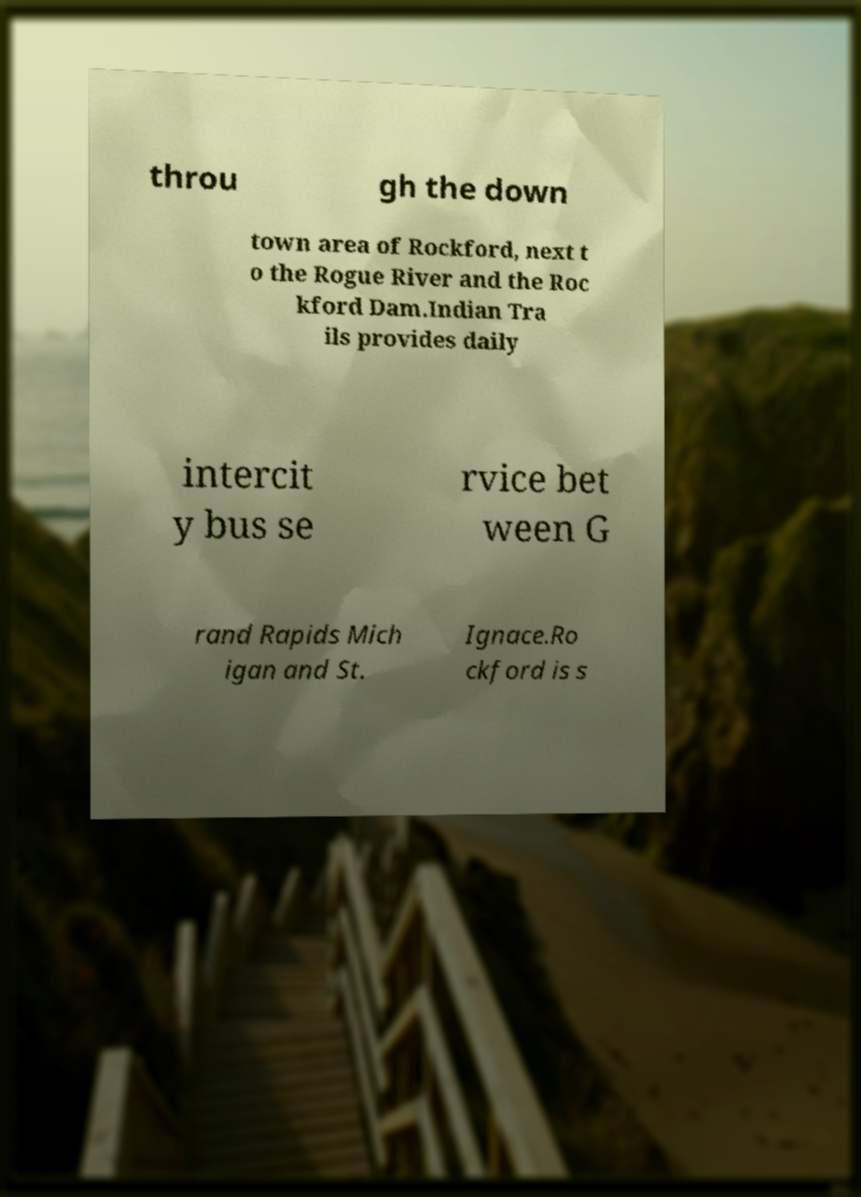There's text embedded in this image that I need extracted. Can you transcribe it verbatim? throu gh the down town area of Rockford, next t o the Rogue River and the Roc kford Dam.Indian Tra ils provides daily intercit y bus se rvice bet ween G rand Rapids Mich igan and St. Ignace.Ro ckford is s 